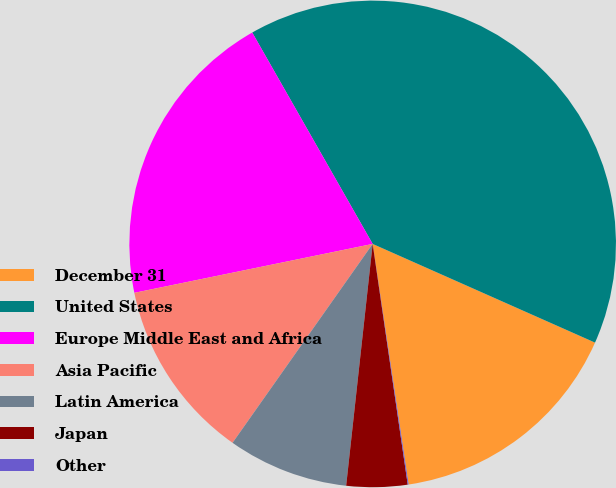Convert chart to OTSL. <chart><loc_0><loc_0><loc_500><loc_500><pie_chart><fcel>December 31<fcel>United States<fcel>Europe Middle East and Africa<fcel>Asia Pacific<fcel>Latin America<fcel>Japan<fcel>Other<nl><fcel>15.99%<fcel>39.89%<fcel>19.98%<fcel>12.01%<fcel>8.03%<fcel>4.04%<fcel>0.06%<nl></chart> 